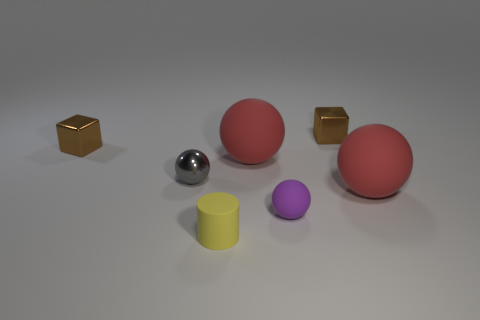Add 2 large gray cylinders. How many objects exist? 9 Subtract all spheres. How many objects are left? 3 Subtract 0 red cylinders. How many objects are left? 7 Subtract all brown shiny cubes. Subtract all yellow rubber things. How many objects are left? 4 Add 6 tiny yellow objects. How many tiny yellow objects are left? 7 Add 7 tiny cylinders. How many tiny cylinders exist? 8 